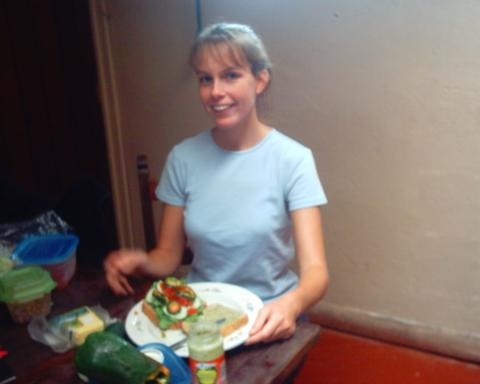Describe the objects in this image and their specific colors. I can see people in black, brown, lightblue, and darkgray tones, dining table in black, brown, and maroon tones, dining table in black, maroon, and brown tones, sandwich in black, beige, olive, and brown tones, and bottle in black, olive, darkgray, and beige tones in this image. 